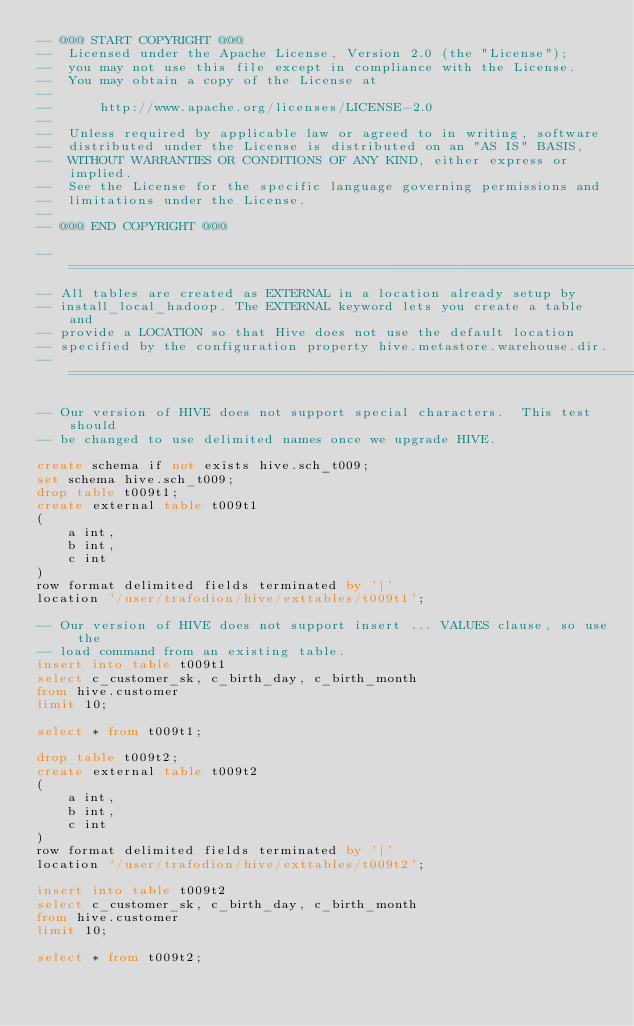<code> <loc_0><loc_0><loc_500><loc_500><_SQL_>-- @@@ START COPYRIGHT @@@
--  Licensed under the Apache License, Version 2.0 (the "License");
--  you may not use this file except in compliance with the License.
--  You may obtain a copy of the License at
--
--      http://www.apache.org/licenses/LICENSE-2.0
--
--  Unless required by applicable law or agreed to in writing, software
--  distributed under the License is distributed on an "AS IS" BASIS,
--  WITHOUT WARRANTIES OR CONDITIONS OF ANY KIND, either express or implied.
--  See the License for the specific language governing permissions and
--  limitations under the License.
--
-- @@@ END COPYRIGHT @@@

-- ============================================================================
-- All tables are created as EXTERNAL in a location already setup by 
-- install_local_hadoop. The EXTERNAL keyword lets you create a table and 
-- provide a LOCATION so that Hive does not use the default location 
-- specified by the configuration property hive.metastore.warehouse.dir.
-- ============================================================================

-- Our version of HIVE does not support special characters.  This test should 
-- be changed to use delimited names once we upgrade HIVE.

create schema if not exists hive.sch_t009;
set schema hive.sch_t009;
drop table t009t1;
create external table t009t1
(
    a int,
    b int, 
    c int
)
row format delimited fields terminated by '|'
location '/user/trafodion/hive/exttables/t009t1';

-- Our version of HIVE does not support insert ... VALUES clause, so use the
-- load command from an existing table.
insert into table t009t1
select c_customer_sk, c_birth_day, c_birth_month
from hive.customer
limit 10;

select * from t009t1;

drop table t009t2;
create external table t009t2
(
    a int,
    b int,
    c int
)
row format delimited fields terminated by '|'
location '/user/trafodion/hive/exttables/t009t2';

insert into table t009t2
select c_customer_sk, c_birth_day, c_birth_month
from hive.customer
limit 10;

select * from t009t2;


</code> 